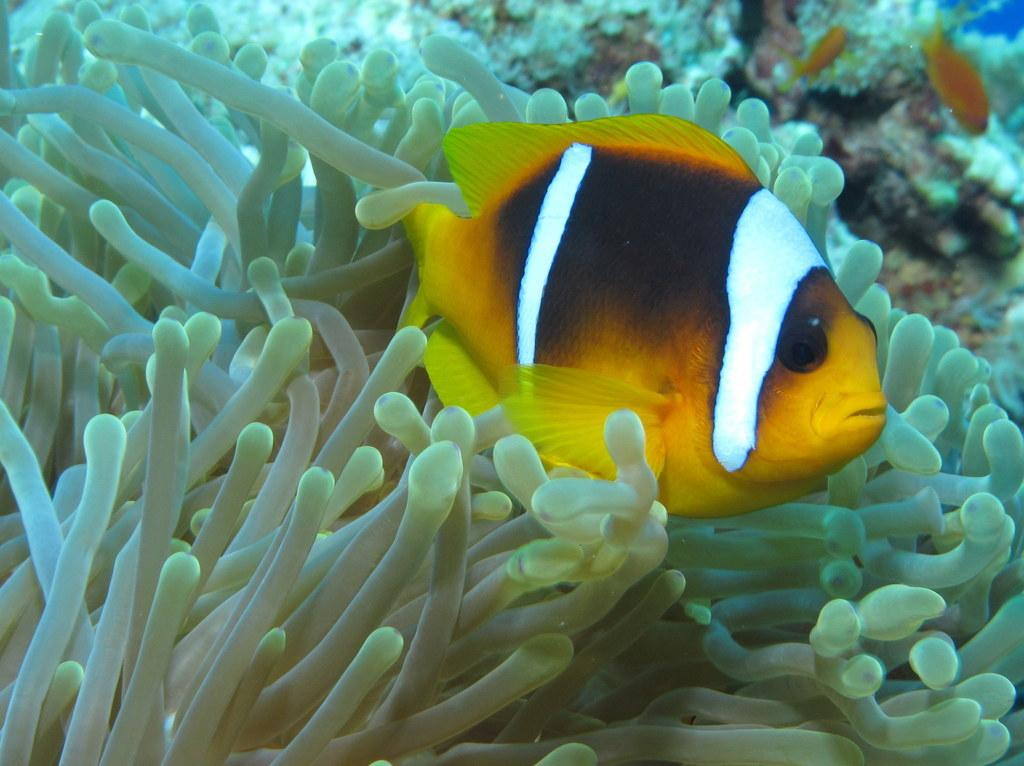What type of animal is in the image? There is a fish in the image. Where was the image taken? The image was taken from the ocean. What type of roof can be seen on the fish in the image? There is no roof present on the fish in the image, as fish do not have roofs. 